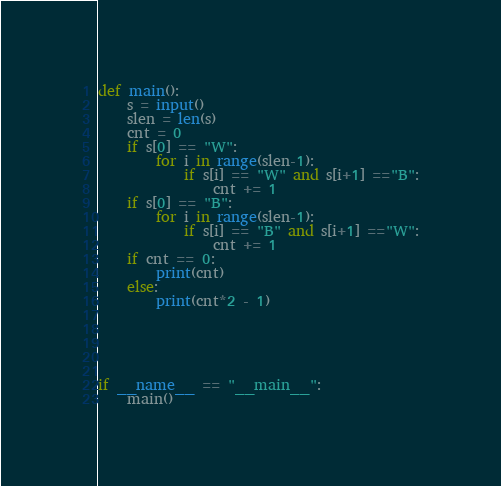Convert code to text. <code><loc_0><loc_0><loc_500><loc_500><_Python_>def main():
    s = input()
    slen = len(s)
    cnt = 0
    if s[0] == "W":
        for i in range(slen-1):
            if s[i] == "W" and s[i+1] =="B":
                cnt += 1
    if s[0] == "B":
        for i in range(slen-1):
            if s[i] == "B" and s[i+1] =="W":
                cnt += 1
    if cnt == 0:
        print(cnt)
    else:
        print(cnt*2 - 1)
    

 
    
    
if __name__ == "__main__":
    main()</code> 